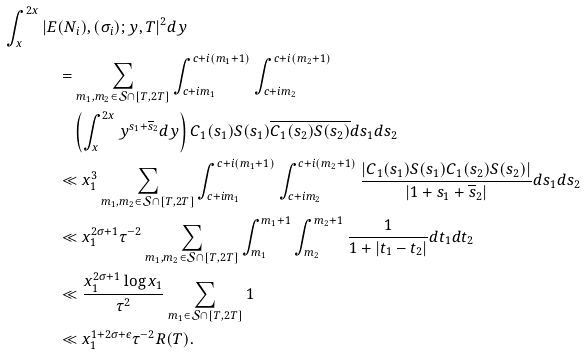Convert formula to latex. <formula><loc_0><loc_0><loc_500><loc_500>\int _ { x } ^ { 2 x } | E & ( N _ { i } ) , ( \sigma _ { i } ) ; y , T | ^ { 2 } d y \\ & = \sum _ { m _ { 1 } , m _ { 2 } \in \mathcal { S } \cap [ T , 2 T ] } \int _ { c + i m _ { 1 } } ^ { c + i ( m _ { 1 } + 1 ) } \int _ { c + i m _ { 2 } } ^ { c + i ( m _ { 2 } + 1 ) } \\ & \quad \left ( \int _ { x } ^ { 2 x } y ^ { s _ { 1 } + \overline { s } _ { 2 } } d y \right ) C _ { 1 } ( s _ { 1 } ) S ( s _ { 1 } ) \overline { C _ { 1 } ( s _ { 2 } ) } \overline { S ( s _ { 2 } ) } d s _ { 1 } d s _ { 2 } \\ & \ll x _ { 1 } ^ { 3 } \sum _ { m _ { 1 } , m _ { 2 } \in \mathcal { S } \cap [ T , 2 T ] } \int _ { c + i m _ { 1 } } ^ { c + i ( m _ { 1 } + 1 ) } \int _ { c + i m _ { 2 } } ^ { c + i ( m _ { 2 } + 1 ) } \frac { | C _ { 1 } ( s _ { 1 } ) S ( s _ { 1 } ) C _ { 1 } ( s _ { 2 } ) S ( s _ { 2 } ) | } { | 1 + s _ { 1 } + \overline { s } _ { 2 } | } d s _ { 1 } d s _ { 2 } \\ & \ll x _ { 1 } ^ { 2 \sigma + 1 } \tau ^ { - 2 } \sum _ { m _ { 1 } , m _ { 2 } \in \mathcal { S } \cap [ T , 2 T ] } \int _ { m _ { 1 } } ^ { m _ { 1 } + 1 } \int _ { m _ { 2 } } ^ { m _ { 2 } + 1 } \frac { 1 } { 1 + | t _ { 1 } - t _ { 2 } | } d t _ { 1 } d t _ { 2 } \\ & \ll \frac { x _ { 1 } ^ { 2 \sigma + 1 } \log { x _ { 1 } } } { \tau ^ { 2 } } \sum _ { m _ { 1 } \in \mathcal { S } \cap [ T , 2 T ] } 1 \\ & \ll x _ { 1 } ^ { 1 + 2 \sigma + \epsilon } \tau ^ { - 2 } R ( T ) .</formula> 